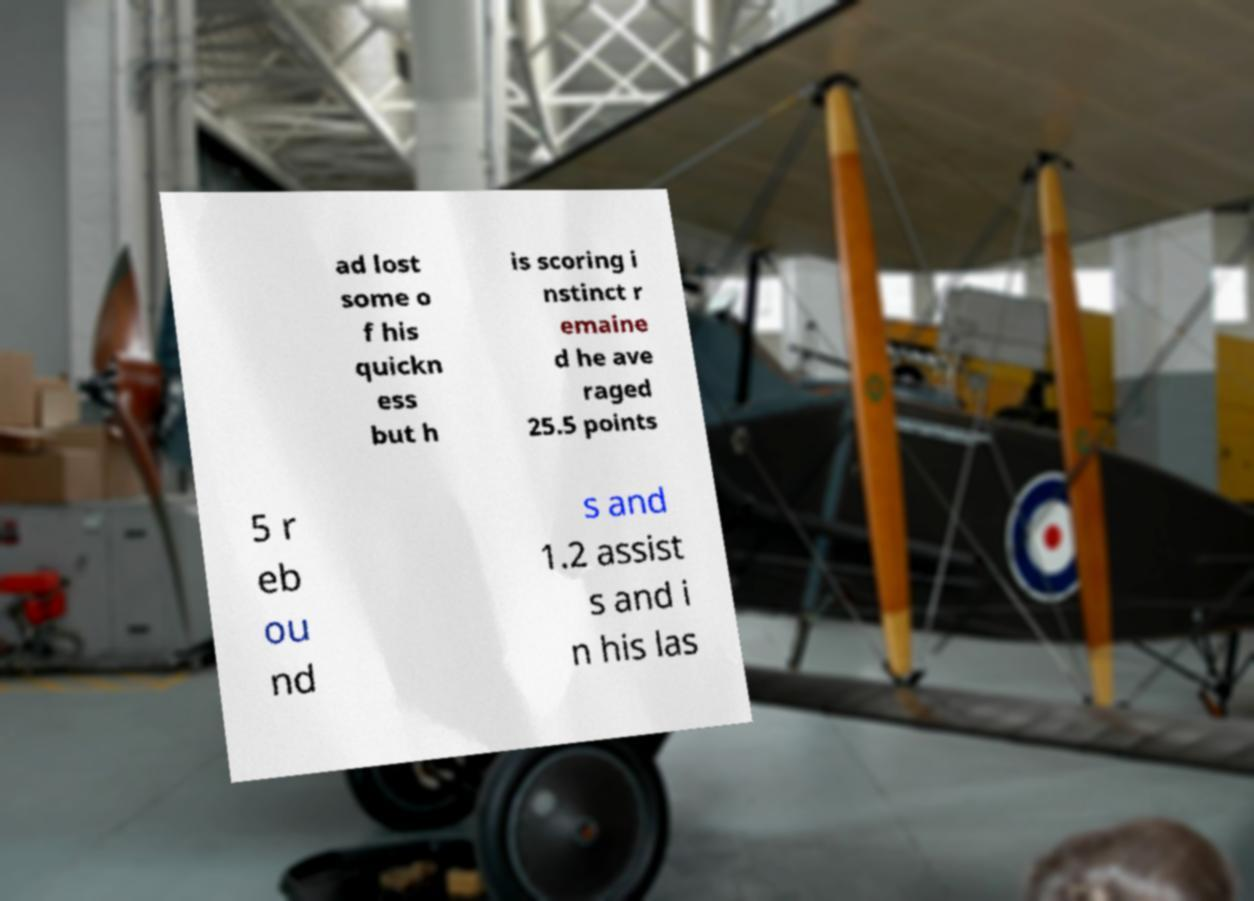Could you extract and type out the text from this image? ad lost some o f his quickn ess but h is scoring i nstinct r emaine d he ave raged 25.5 points 5 r eb ou nd s and 1.2 assist s and i n his las 